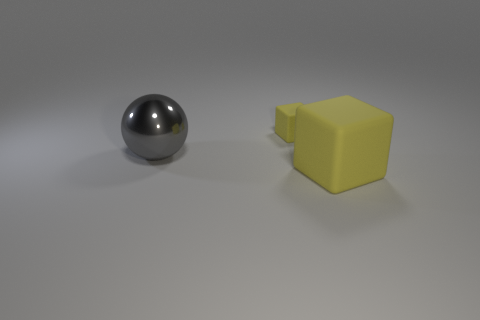There is a large yellow thing that is the same shape as the tiny rubber object; what is it made of?
Make the answer very short. Rubber. Are there more large gray metallic spheres that are right of the small block than large matte objects that are behind the large gray metal thing?
Your answer should be very brief. No. What is the shape of the other object that is made of the same material as the big yellow object?
Provide a succinct answer. Cube. Are there more small yellow rubber cubes that are behind the large gray metallic ball than small brown metallic balls?
Provide a succinct answer. Yes. What number of large blocks are the same color as the tiny cube?
Offer a very short reply. 1. What number of other objects are there of the same color as the big cube?
Your answer should be compact. 1. Is the number of yellow matte blocks greater than the number of tiny cyan blocks?
Your answer should be very brief. Yes. What is the gray ball made of?
Your answer should be compact. Metal. There is a matte block behind the gray shiny sphere; does it have the same size as the big shiny sphere?
Provide a succinct answer. No. How big is the object that is in front of the big gray sphere?
Offer a very short reply. Large. 